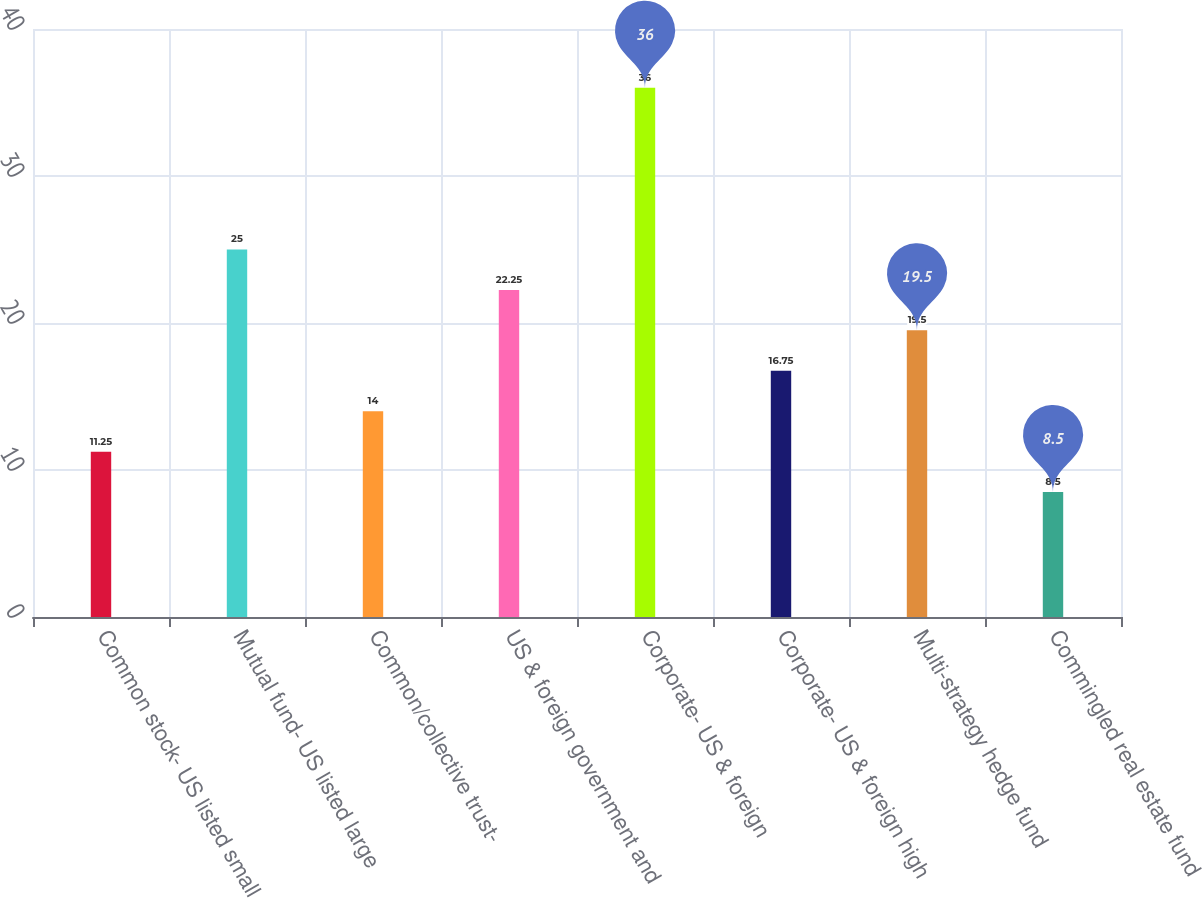Convert chart. <chart><loc_0><loc_0><loc_500><loc_500><bar_chart><fcel>Common stock- US listed small<fcel>Mutual fund- US listed large<fcel>Common/collective trust-<fcel>US & foreign government and<fcel>Corporate- US & foreign<fcel>Corporate- US & foreign high<fcel>Multi-strategy hedge fund<fcel>Commingled real estate fund<nl><fcel>11.25<fcel>25<fcel>14<fcel>22.25<fcel>36<fcel>16.75<fcel>19.5<fcel>8.5<nl></chart> 